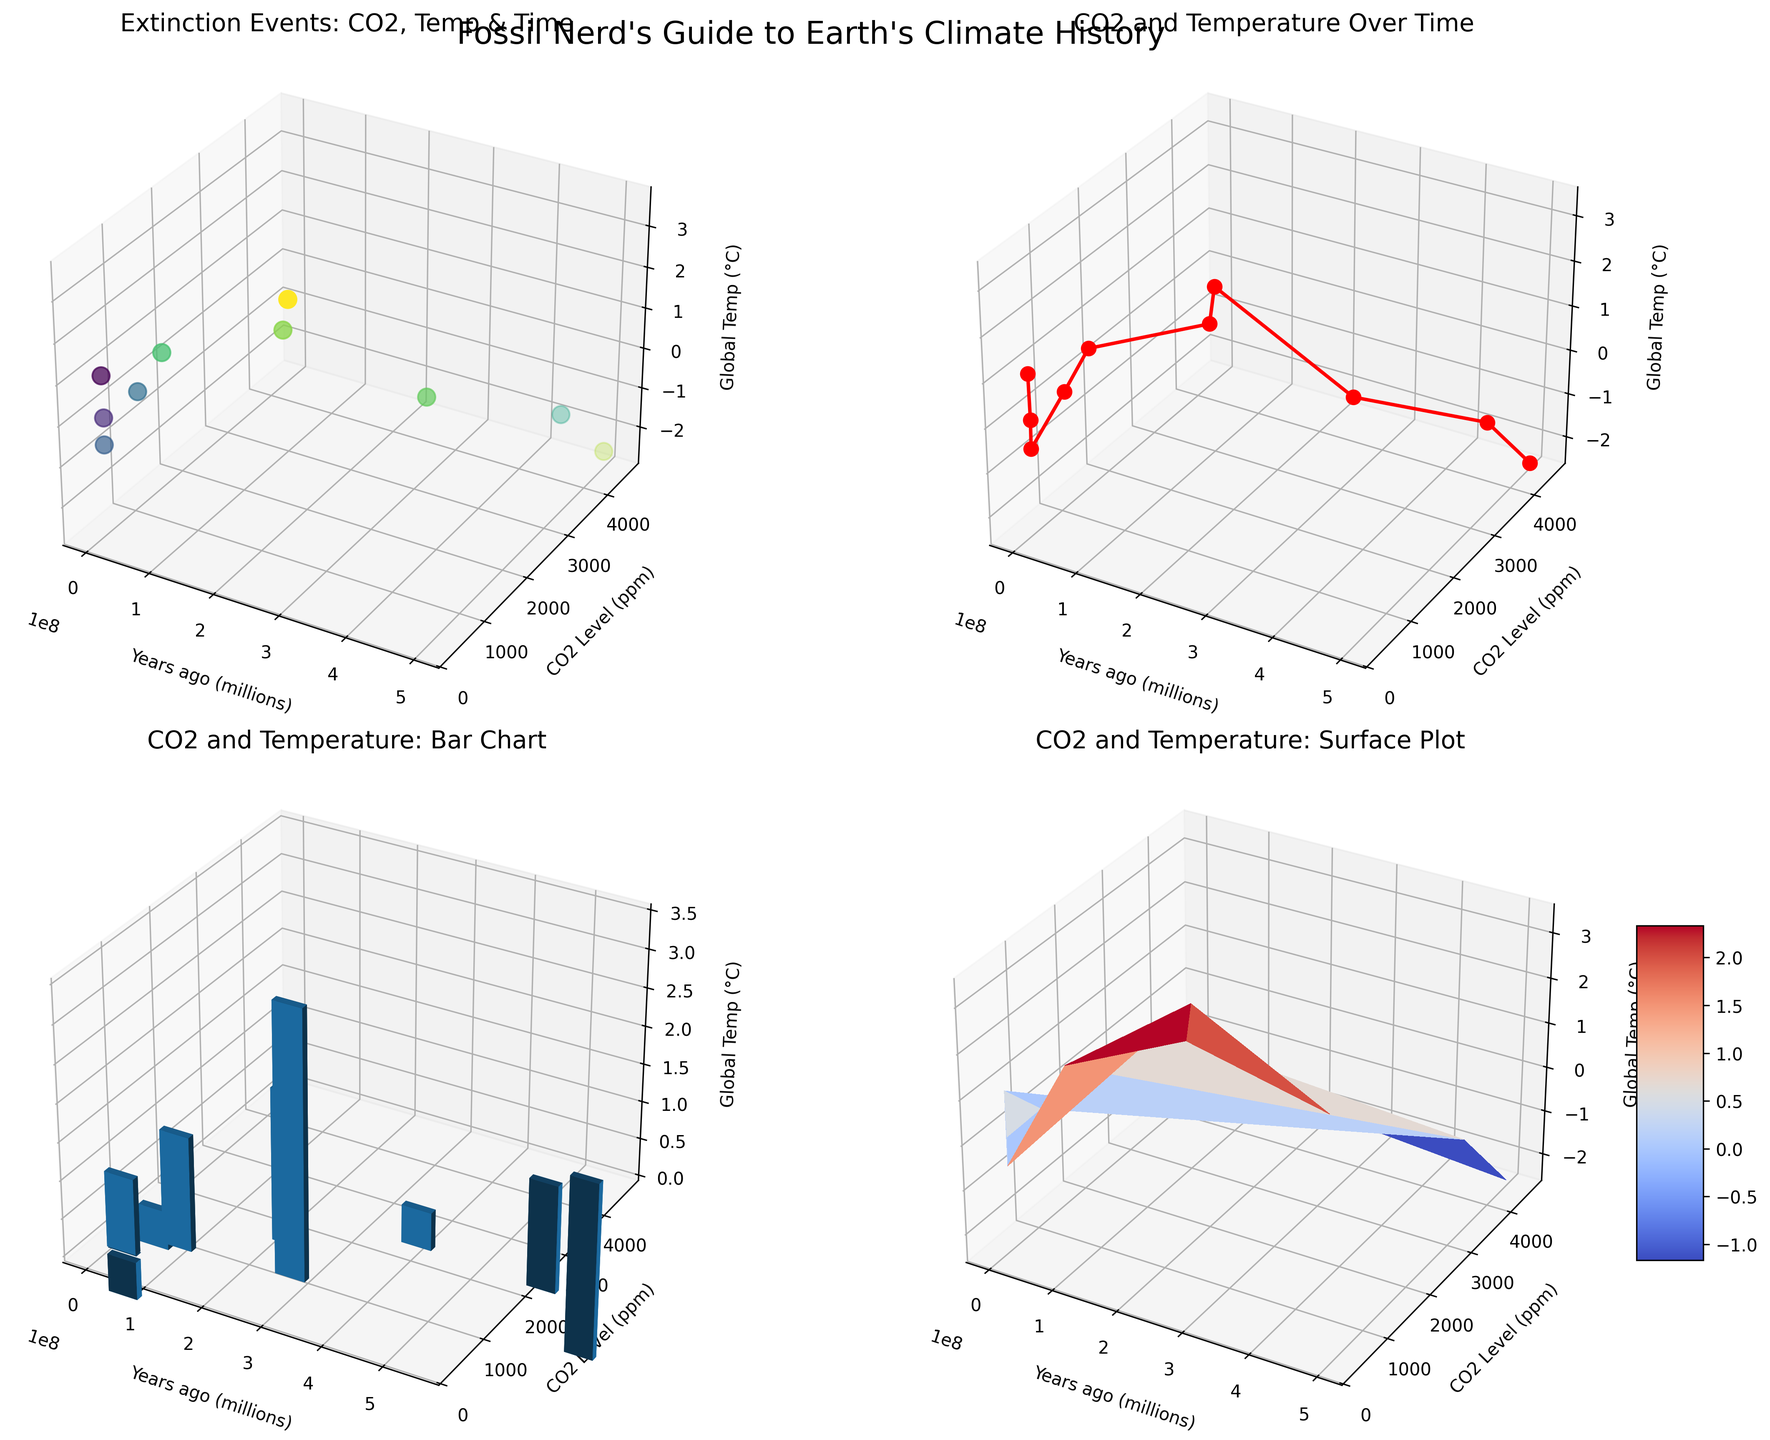Which extinction event had the highest CO2 level? The first subplot highlights various extinction events. Checking the scatter plot, the Cambrian-Ordovician event has the highest point on the CO2 level axis.
Answer: Cambrian-Ordovician How does the global temperature change from the Permian-Triassic to the Triassic-Jurassic events? In the second subplot, observe the changes in global temperature between the two events marked along the time axis. The temperature decreases from 3.5°C during the Permian-Triassic to 2.0°C during the Triassic-Jurassic.
Answer: Decreases What's the range of CO2 levels during all displayed events? From the first and third subplots, note the minimum and maximum CO2 levels. The range spans from the minimum CO2 level (280 ppm during the Pleistocene) to the maximum CO2 level (4500 ppm during the Cambrian-Ordovician).
Answer: 280 ppm to 4500 ppm Which event on the bar chart had the largest change in global temperature? In the third subplot, focus on the height variations of the bars representing global temperatures. The highest bar represents the largest temperature change, which is seen during the Permian-Triassic event.
Answer: Permian-Triassic Between which two events did the CO2 level drop the most? In the second subplot's line plot, analyze the steepest line segment. The greatest CO2 decrease occurred between the Cambrian-Ordovician and Late Devonian events (4500 ppm to 2200 ppm).
Answer: Cambrian-Ordovician to Late Devonian What color shade does the highest extinction event show in the surface plot? In the fourth subplot, find the highest point on the 'ExtinctSpecies' color scale and observe its shade on the surface plot. The highest extinction event corresponds to a yellow-ish hue in the surface plot.
Answer: Yellow-ish How many data points are there in the scatter plot? Count the number of plotted points in the first subplot's scatter plot. There are 10 plotted points representing different events.
Answer: 10 Which event had the lowest global temperature change? Analyze all subplots focusing on the global temperature axis. The scatter and surface plots show that the Cambrian-Ordovician event had the lowest temperature at -2.5°C.
Answer: Cambrian-Ordovician 